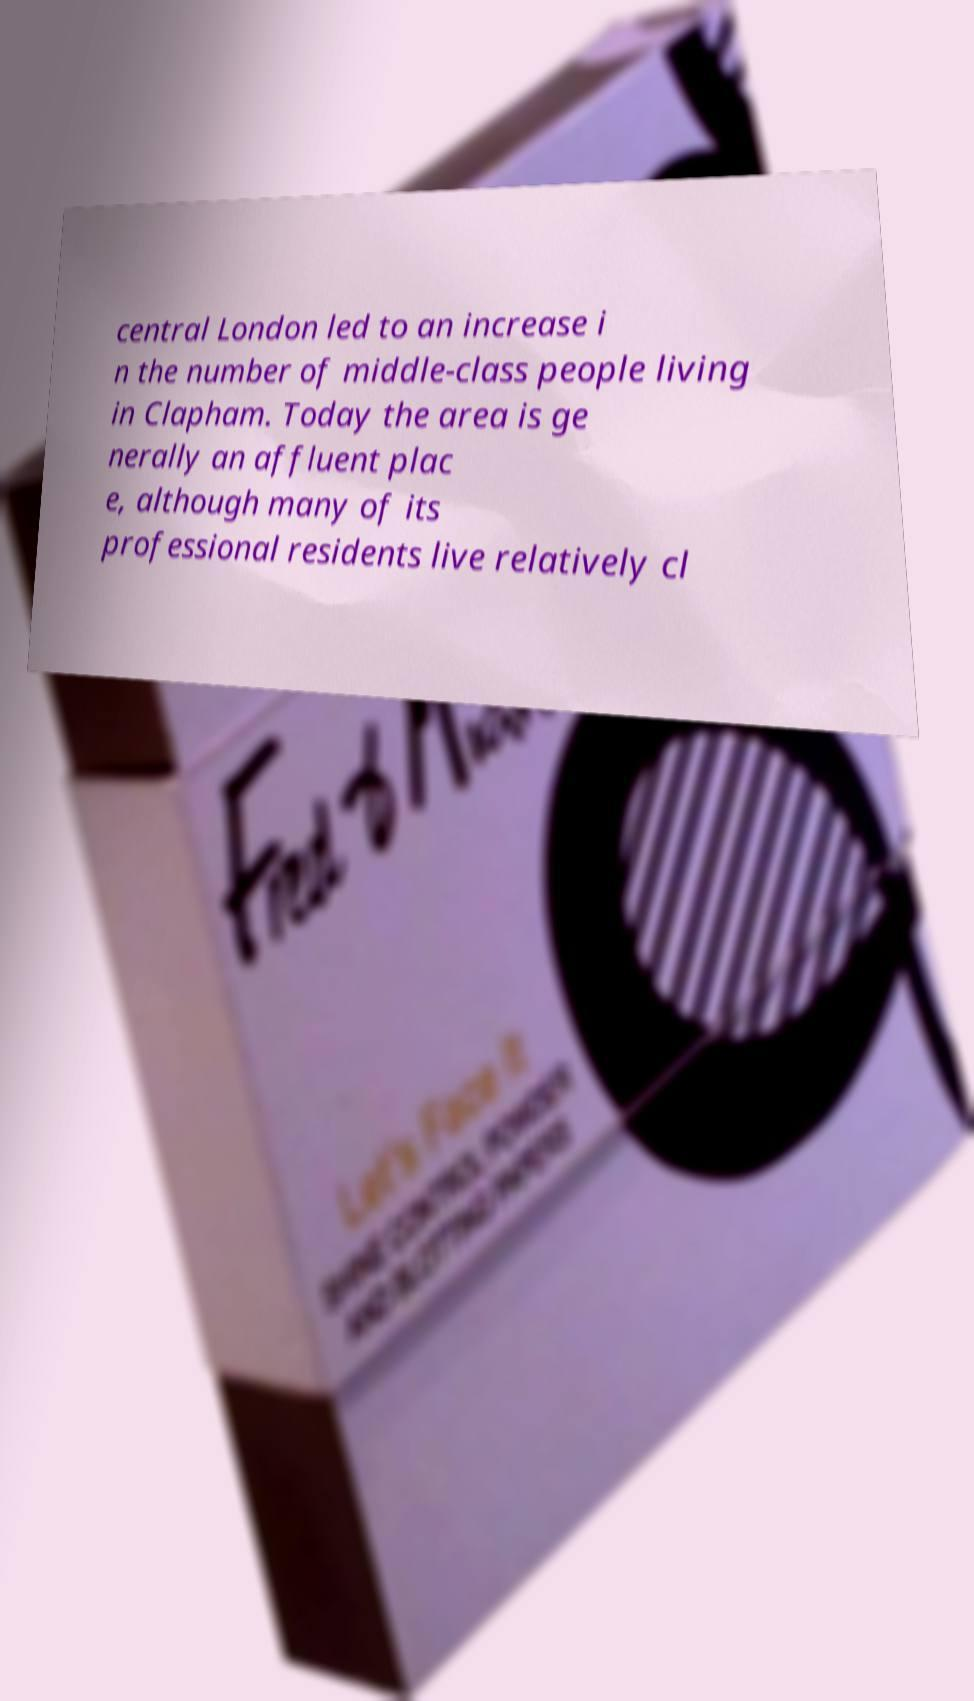For documentation purposes, I need the text within this image transcribed. Could you provide that? central London led to an increase i n the number of middle-class people living in Clapham. Today the area is ge nerally an affluent plac e, although many of its professional residents live relatively cl 